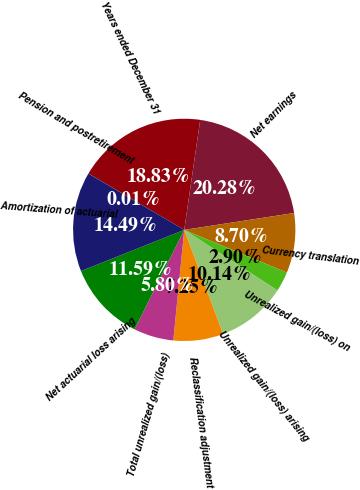<chart> <loc_0><loc_0><loc_500><loc_500><pie_chart><fcel>Years ended December 31<fcel>Net earnings<fcel>Currency translation<fcel>Unrealized gain/(loss) on<fcel>Unrealized gain/(loss) arising<fcel>Reclassification adjustment<fcel>Total unrealized gain/(loss)<fcel>Net actuarial loss arising<fcel>Amortization of actuarial<fcel>Pension and postretirement<nl><fcel>18.83%<fcel>20.28%<fcel>8.7%<fcel>2.9%<fcel>10.14%<fcel>7.25%<fcel>5.8%<fcel>11.59%<fcel>14.49%<fcel>0.01%<nl></chart> 